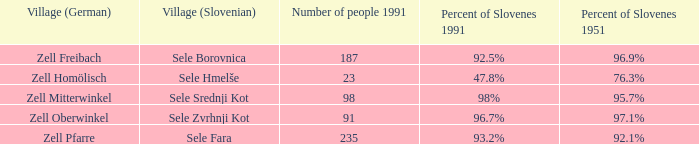Can you give the name of the german village with a 9 Zell Freibach. 